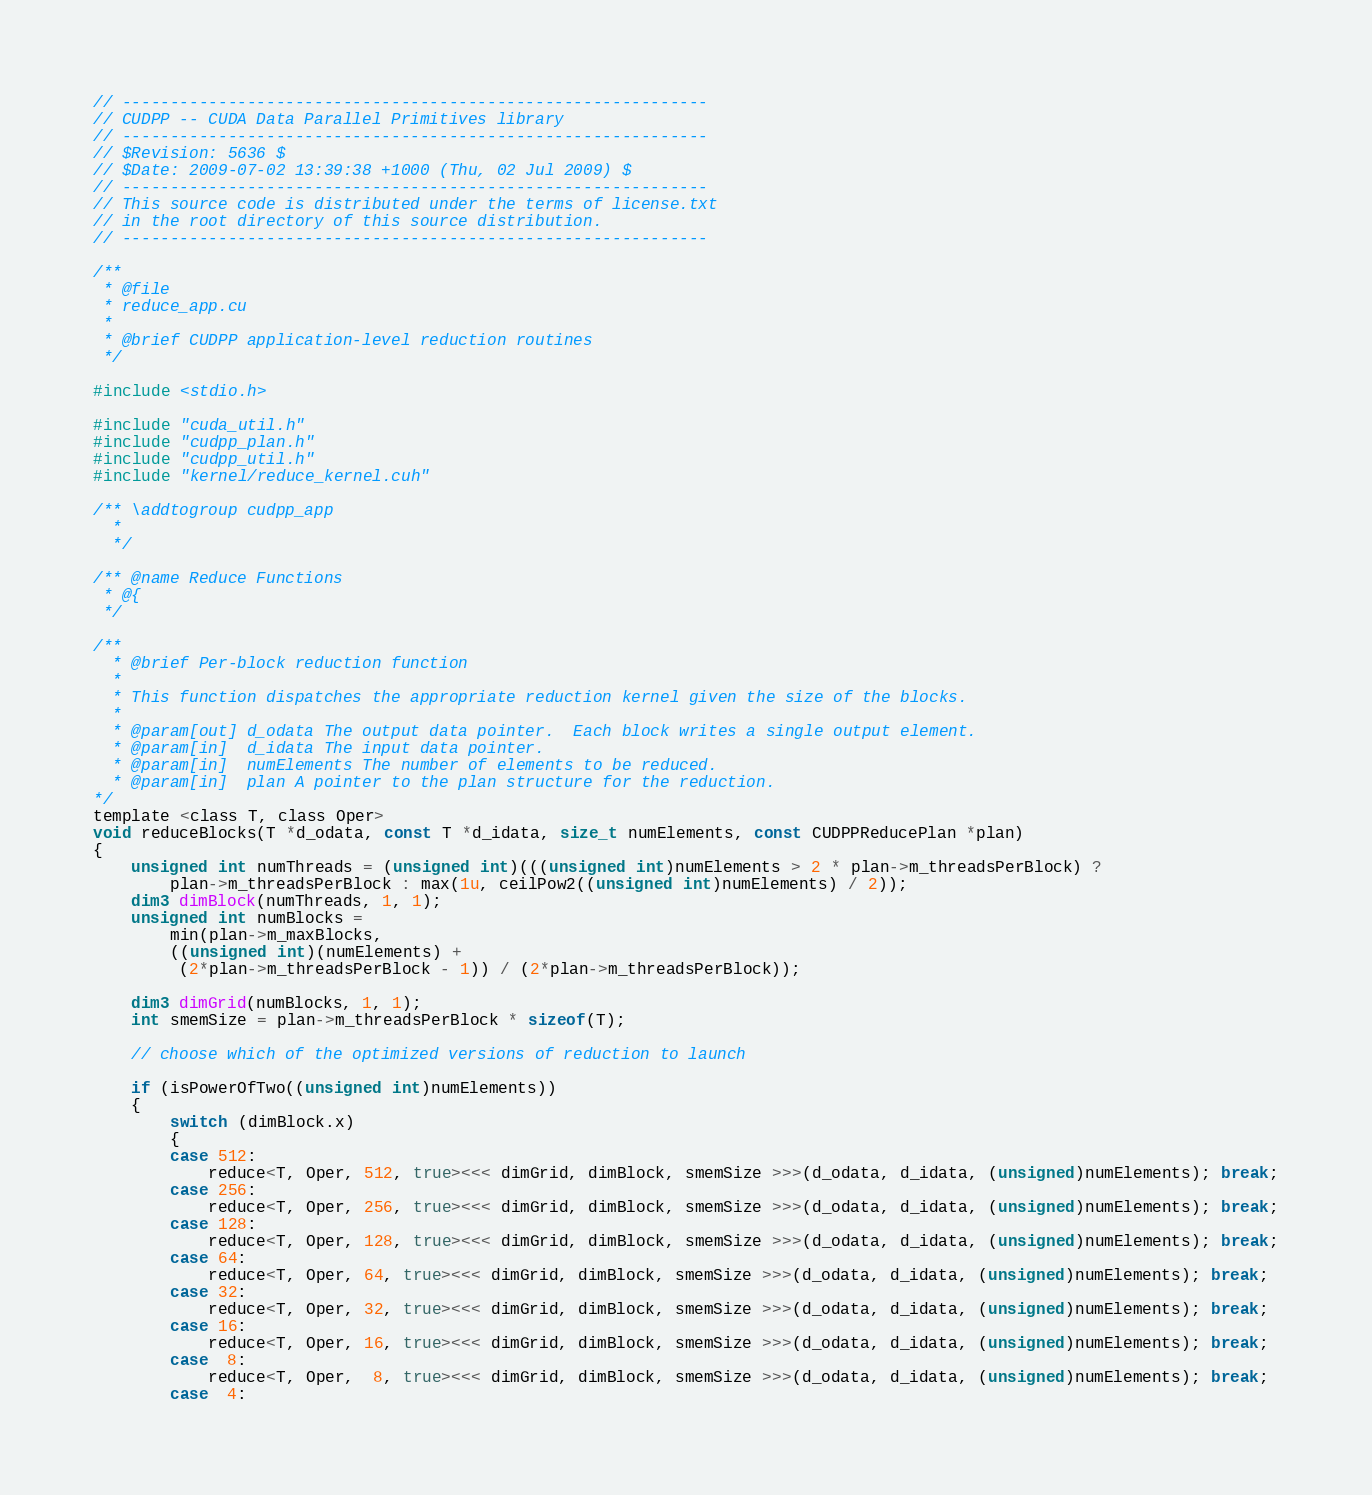<code> <loc_0><loc_0><loc_500><loc_500><_Cuda_>// -------------------------------------------------------------
// CUDPP -- CUDA Data Parallel Primitives library
// -------------------------------------------------------------
// $Revision: 5636 $
// $Date: 2009-07-02 13:39:38 +1000 (Thu, 02 Jul 2009) $
// ------------------------------------------------------------- 
// This source code is distributed under the terms of license.txt 
// in the root directory of this source distribution.
// ------------------------------------------------------------- 

/**
 * @file
 * reduce_app.cu
 *
 * @brief CUDPP application-level reduction routines
 */
 
#include <stdio.h>

#include "cuda_util.h"
#include "cudpp_plan.h"
#include "cudpp_util.h"
#include "kernel/reduce_kernel.cuh"

/** \addtogroup cudpp_app
  *
  */

/** @name Reduce Functions
 * @{
 */

/**
  * @brief Per-block reduction function
  *
  * This function dispatches the appropriate reduction kernel given the size of the blocks.
  *
  * @param[out] d_odata The output data pointer.  Each block writes a single output element.
  * @param[in]  d_idata The input data pointer.  
  * @param[in]  numElements The number of elements to be reduced.
  * @param[in]  plan A pointer to the plan structure for the reduction.
*/
template <class T, class Oper>
void reduceBlocks(T *d_odata, const T *d_idata, size_t numElements, const CUDPPReducePlan *plan)
{
    unsigned int numThreads = (unsigned int)(((unsigned int)numElements > 2 * plan->m_threadsPerBlock) ?
        plan->m_threadsPerBlock : max(1u, ceilPow2((unsigned int)numElements) / 2));
    dim3 dimBlock(numThreads, 1, 1);
    unsigned int numBlocks =
        min(plan->m_maxBlocks,
        ((unsigned int)(numElements) +
         (2*plan->m_threadsPerBlock - 1)) / (2*plan->m_threadsPerBlock));

    dim3 dimGrid(numBlocks, 1, 1);
    int smemSize = plan->m_threadsPerBlock * sizeof(T);

    // choose which of the optimized versions of reduction to launch
    
    if (isPowerOfTwo((unsigned int)numElements))
    {
        switch (dimBlock.x)
        {
        case 512:
            reduce<T, Oper, 512, true><<< dimGrid, dimBlock, smemSize >>>(d_odata, d_idata, (unsigned)numElements); break;
        case 256:
            reduce<T, Oper, 256, true><<< dimGrid, dimBlock, smemSize >>>(d_odata, d_idata, (unsigned)numElements); break;
        case 128:
            reduce<T, Oper, 128, true><<< dimGrid, dimBlock, smemSize >>>(d_odata, d_idata, (unsigned)numElements); break;
        case 64:
            reduce<T, Oper, 64, true><<< dimGrid, dimBlock, smemSize >>>(d_odata, d_idata, (unsigned)numElements); break;
        case 32:
            reduce<T, Oper, 32, true><<< dimGrid, dimBlock, smemSize >>>(d_odata, d_idata, (unsigned)numElements); break;
        case 16:
            reduce<T, Oper, 16, true><<< dimGrid, dimBlock, smemSize >>>(d_odata, d_idata, (unsigned)numElements); break;
        case  8:
            reduce<T, Oper,  8, true><<< dimGrid, dimBlock, smemSize >>>(d_odata, d_idata, (unsigned)numElements); break;
        case  4:</code> 